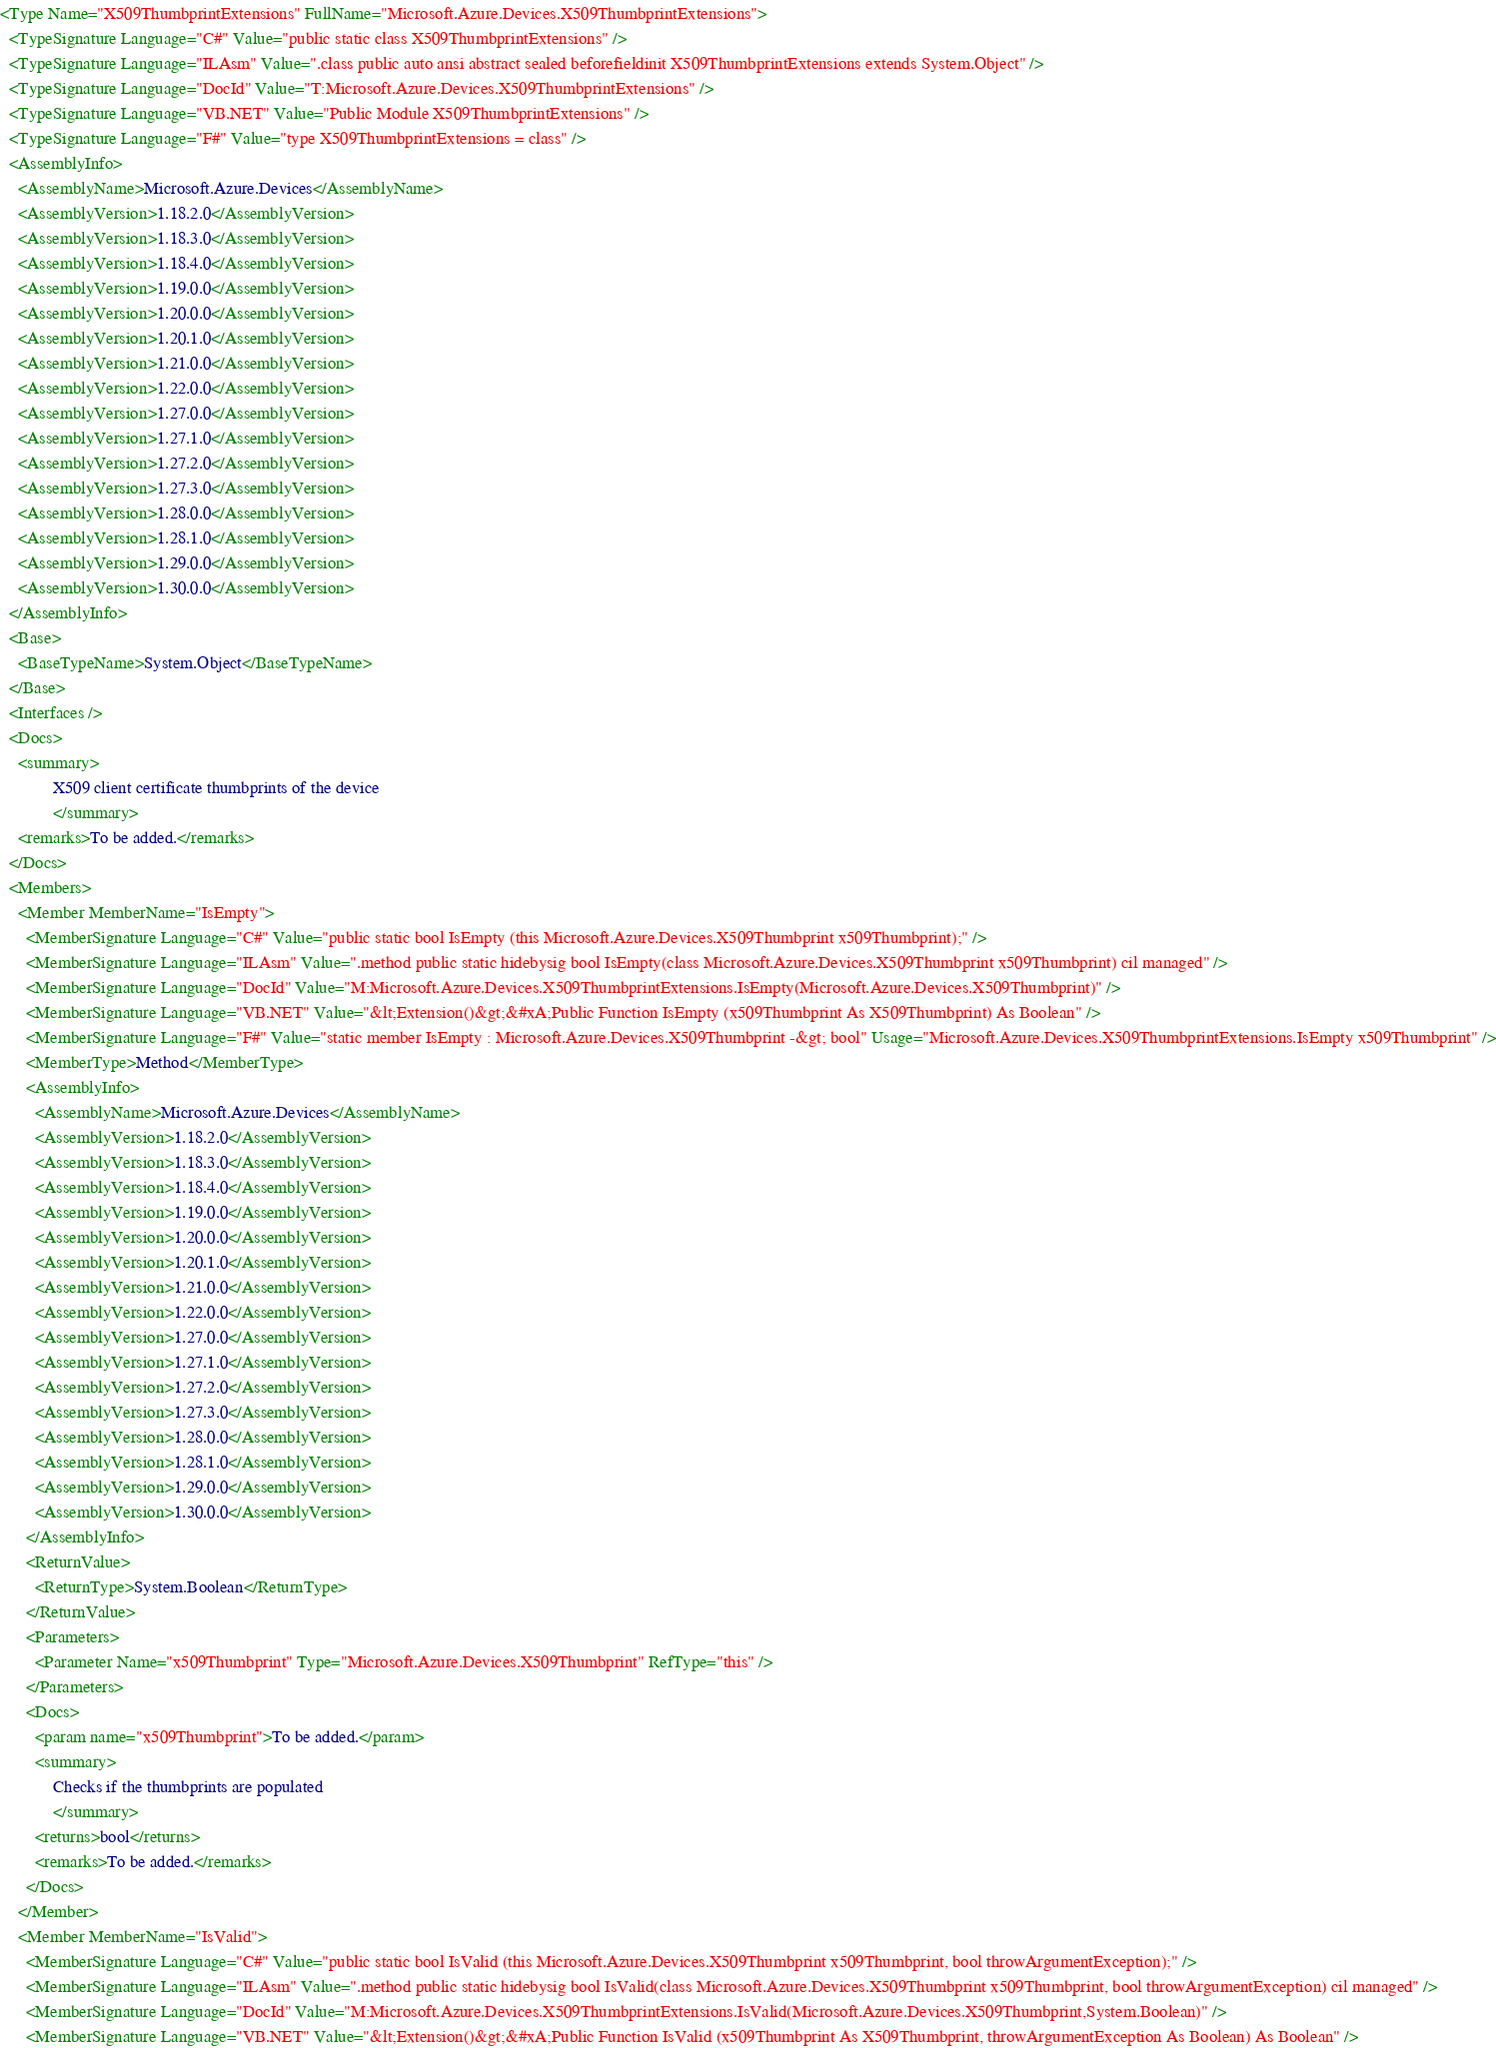Convert code to text. <code><loc_0><loc_0><loc_500><loc_500><_XML_><Type Name="X509ThumbprintExtensions" FullName="Microsoft.Azure.Devices.X509ThumbprintExtensions">
  <TypeSignature Language="C#" Value="public static class X509ThumbprintExtensions" />
  <TypeSignature Language="ILAsm" Value=".class public auto ansi abstract sealed beforefieldinit X509ThumbprintExtensions extends System.Object" />
  <TypeSignature Language="DocId" Value="T:Microsoft.Azure.Devices.X509ThumbprintExtensions" />
  <TypeSignature Language="VB.NET" Value="Public Module X509ThumbprintExtensions" />
  <TypeSignature Language="F#" Value="type X509ThumbprintExtensions = class" />
  <AssemblyInfo>
    <AssemblyName>Microsoft.Azure.Devices</AssemblyName>
    <AssemblyVersion>1.18.2.0</AssemblyVersion>
    <AssemblyVersion>1.18.3.0</AssemblyVersion>
    <AssemblyVersion>1.18.4.0</AssemblyVersion>
    <AssemblyVersion>1.19.0.0</AssemblyVersion>
    <AssemblyVersion>1.20.0.0</AssemblyVersion>
    <AssemblyVersion>1.20.1.0</AssemblyVersion>
    <AssemblyVersion>1.21.0.0</AssemblyVersion>
    <AssemblyVersion>1.22.0.0</AssemblyVersion>
    <AssemblyVersion>1.27.0.0</AssemblyVersion>
    <AssemblyVersion>1.27.1.0</AssemblyVersion>
    <AssemblyVersion>1.27.2.0</AssemblyVersion>
    <AssemblyVersion>1.27.3.0</AssemblyVersion>
    <AssemblyVersion>1.28.0.0</AssemblyVersion>
    <AssemblyVersion>1.28.1.0</AssemblyVersion>
    <AssemblyVersion>1.29.0.0</AssemblyVersion>
    <AssemblyVersion>1.30.0.0</AssemblyVersion>
  </AssemblyInfo>
  <Base>
    <BaseTypeName>System.Object</BaseTypeName>
  </Base>
  <Interfaces />
  <Docs>
    <summary>
            X509 client certificate thumbprints of the device
            </summary>
    <remarks>To be added.</remarks>
  </Docs>
  <Members>
    <Member MemberName="IsEmpty">
      <MemberSignature Language="C#" Value="public static bool IsEmpty (this Microsoft.Azure.Devices.X509Thumbprint x509Thumbprint);" />
      <MemberSignature Language="ILAsm" Value=".method public static hidebysig bool IsEmpty(class Microsoft.Azure.Devices.X509Thumbprint x509Thumbprint) cil managed" />
      <MemberSignature Language="DocId" Value="M:Microsoft.Azure.Devices.X509ThumbprintExtensions.IsEmpty(Microsoft.Azure.Devices.X509Thumbprint)" />
      <MemberSignature Language="VB.NET" Value="&lt;Extension()&gt;&#xA;Public Function IsEmpty (x509Thumbprint As X509Thumbprint) As Boolean" />
      <MemberSignature Language="F#" Value="static member IsEmpty : Microsoft.Azure.Devices.X509Thumbprint -&gt; bool" Usage="Microsoft.Azure.Devices.X509ThumbprintExtensions.IsEmpty x509Thumbprint" />
      <MemberType>Method</MemberType>
      <AssemblyInfo>
        <AssemblyName>Microsoft.Azure.Devices</AssemblyName>
        <AssemblyVersion>1.18.2.0</AssemblyVersion>
        <AssemblyVersion>1.18.3.0</AssemblyVersion>
        <AssemblyVersion>1.18.4.0</AssemblyVersion>
        <AssemblyVersion>1.19.0.0</AssemblyVersion>
        <AssemblyVersion>1.20.0.0</AssemblyVersion>
        <AssemblyVersion>1.20.1.0</AssemblyVersion>
        <AssemblyVersion>1.21.0.0</AssemblyVersion>
        <AssemblyVersion>1.22.0.0</AssemblyVersion>
        <AssemblyVersion>1.27.0.0</AssemblyVersion>
        <AssemblyVersion>1.27.1.0</AssemblyVersion>
        <AssemblyVersion>1.27.2.0</AssemblyVersion>
        <AssemblyVersion>1.27.3.0</AssemblyVersion>
        <AssemblyVersion>1.28.0.0</AssemblyVersion>
        <AssemblyVersion>1.28.1.0</AssemblyVersion>
        <AssemblyVersion>1.29.0.0</AssemblyVersion>
        <AssemblyVersion>1.30.0.0</AssemblyVersion>
      </AssemblyInfo>
      <ReturnValue>
        <ReturnType>System.Boolean</ReturnType>
      </ReturnValue>
      <Parameters>
        <Parameter Name="x509Thumbprint" Type="Microsoft.Azure.Devices.X509Thumbprint" RefType="this" />
      </Parameters>
      <Docs>
        <param name="x509Thumbprint">To be added.</param>
        <summary>
            Checks if the thumbprints are populated
            </summary>
        <returns>bool</returns>
        <remarks>To be added.</remarks>
      </Docs>
    </Member>
    <Member MemberName="IsValid">
      <MemberSignature Language="C#" Value="public static bool IsValid (this Microsoft.Azure.Devices.X509Thumbprint x509Thumbprint, bool throwArgumentException);" />
      <MemberSignature Language="ILAsm" Value=".method public static hidebysig bool IsValid(class Microsoft.Azure.Devices.X509Thumbprint x509Thumbprint, bool throwArgumentException) cil managed" />
      <MemberSignature Language="DocId" Value="M:Microsoft.Azure.Devices.X509ThumbprintExtensions.IsValid(Microsoft.Azure.Devices.X509Thumbprint,System.Boolean)" />
      <MemberSignature Language="VB.NET" Value="&lt;Extension()&gt;&#xA;Public Function IsValid (x509Thumbprint As X509Thumbprint, throwArgumentException As Boolean) As Boolean" /></code> 